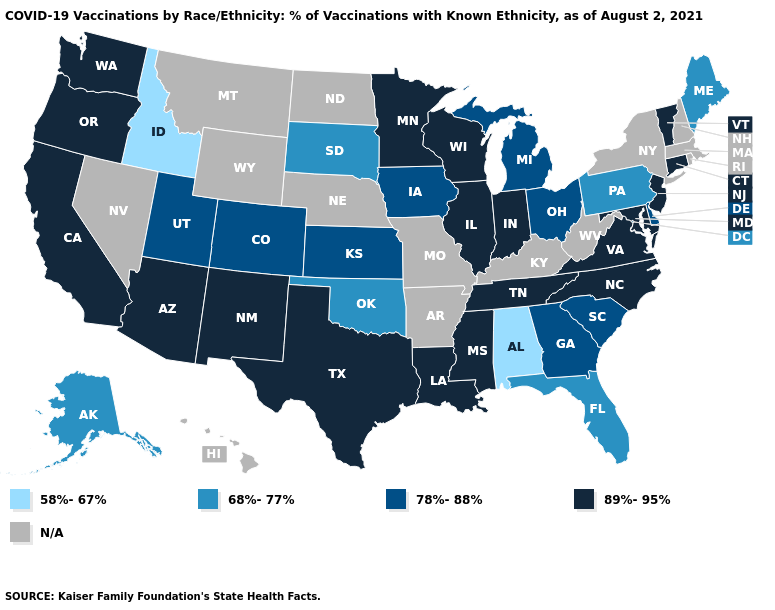Among the states that border Rhode Island , which have the highest value?
Quick response, please. Connecticut. Does Oklahoma have the highest value in the South?
Short answer required. No. Which states have the lowest value in the South?
Short answer required. Alabama. Does the map have missing data?
Be succinct. Yes. What is the highest value in the MidWest ?
Write a very short answer. 89%-95%. Name the states that have a value in the range 78%-88%?
Quick response, please. Colorado, Delaware, Georgia, Iowa, Kansas, Michigan, Ohio, South Carolina, Utah. What is the highest value in the Northeast ?
Give a very brief answer. 89%-95%. What is the lowest value in the USA?
Keep it brief. 58%-67%. How many symbols are there in the legend?
Write a very short answer. 5. What is the lowest value in states that border Washington?
Answer briefly. 58%-67%. Does Maryland have the highest value in the South?
Be succinct. Yes. Which states hav the highest value in the Northeast?
Be succinct. Connecticut, New Jersey, Vermont. What is the lowest value in states that border New Hampshire?
Answer briefly. 68%-77%. Among the states that border Mississippi , which have the lowest value?
Write a very short answer. Alabama. What is the value of Minnesota?
Quick response, please. 89%-95%. 